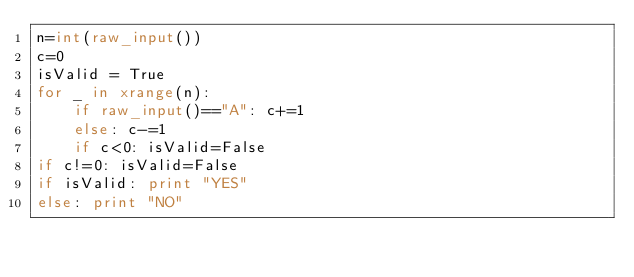Convert code to text. <code><loc_0><loc_0><loc_500><loc_500><_Python_>n=int(raw_input())
c=0
isValid = True
for _ in xrange(n):
    if raw_input()=="A": c+=1
    else: c-=1
    if c<0: isValid=False
if c!=0: isValid=False
if isValid: print "YES"
else: print "NO"</code> 